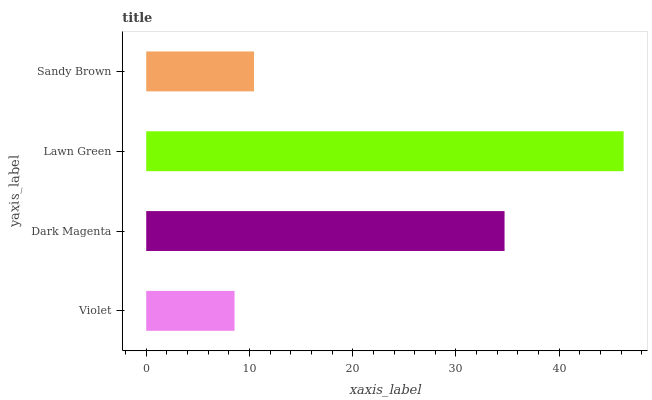Is Violet the minimum?
Answer yes or no. Yes. Is Lawn Green the maximum?
Answer yes or no. Yes. Is Dark Magenta the minimum?
Answer yes or no. No. Is Dark Magenta the maximum?
Answer yes or no. No. Is Dark Magenta greater than Violet?
Answer yes or no. Yes. Is Violet less than Dark Magenta?
Answer yes or no. Yes. Is Violet greater than Dark Magenta?
Answer yes or no. No. Is Dark Magenta less than Violet?
Answer yes or no. No. Is Dark Magenta the high median?
Answer yes or no. Yes. Is Sandy Brown the low median?
Answer yes or no. Yes. Is Sandy Brown the high median?
Answer yes or no. No. Is Lawn Green the low median?
Answer yes or no. No. 